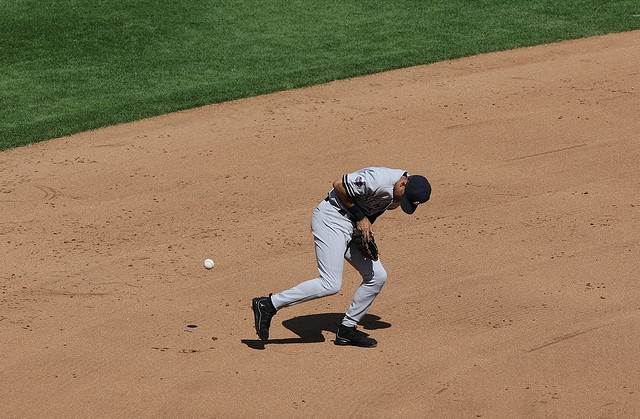Describe the objects in this image and their specific colors. I can see people in darkgreen, black, tan, darkgray, and lightgray tones, baseball glove in darkgreen, black, and gray tones, and sports ball in darkgreen, lightgray, darkgray, and maroon tones in this image. 